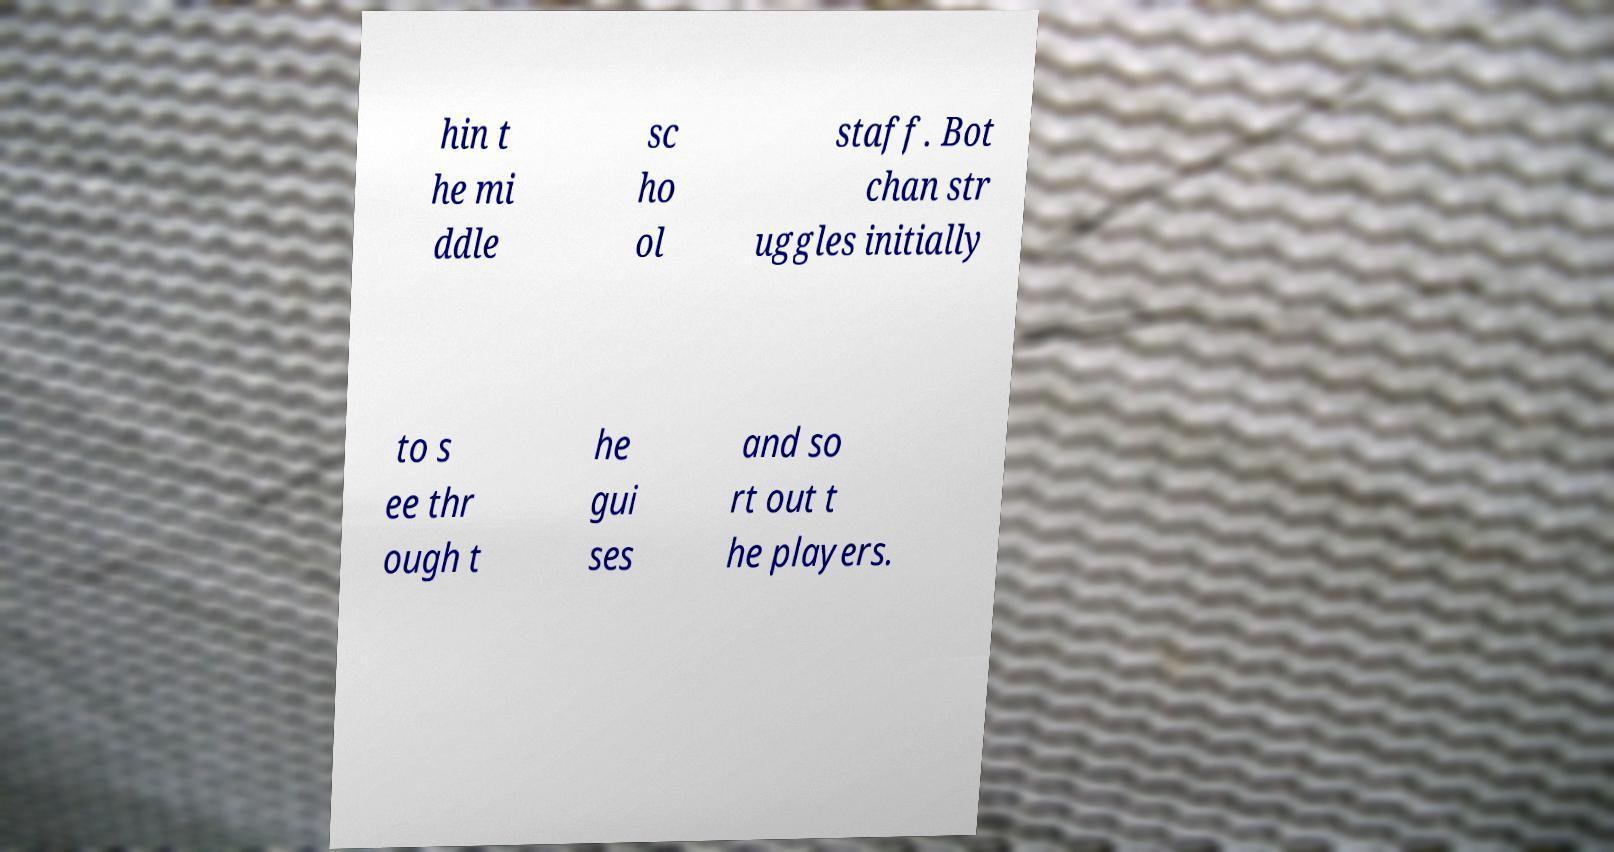Could you extract and type out the text from this image? hin t he mi ddle sc ho ol staff. Bot chan str uggles initially to s ee thr ough t he gui ses and so rt out t he players. 